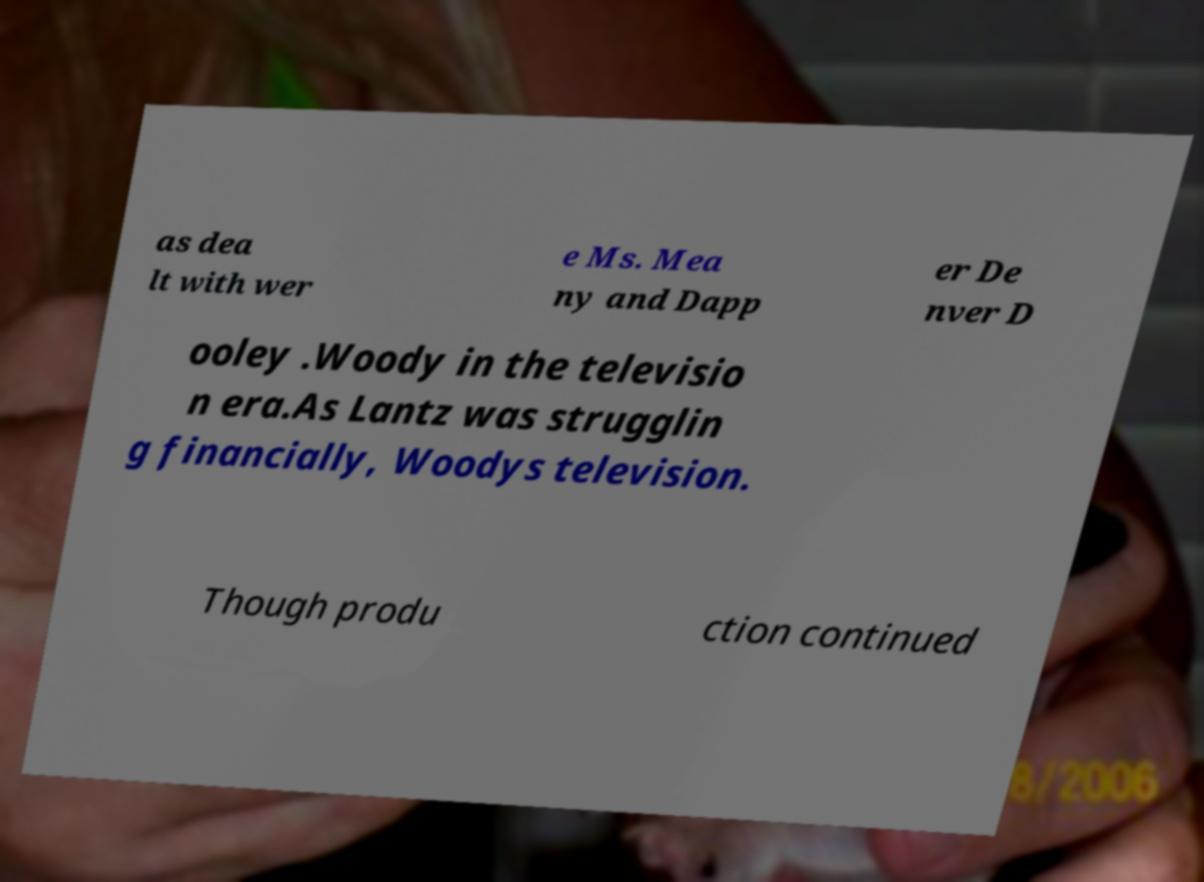I need the written content from this picture converted into text. Can you do that? as dea lt with wer e Ms. Mea ny and Dapp er De nver D ooley .Woody in the televisio n era.As Lantz was strugglin g financially, Woodys television. Though produ ction continued 